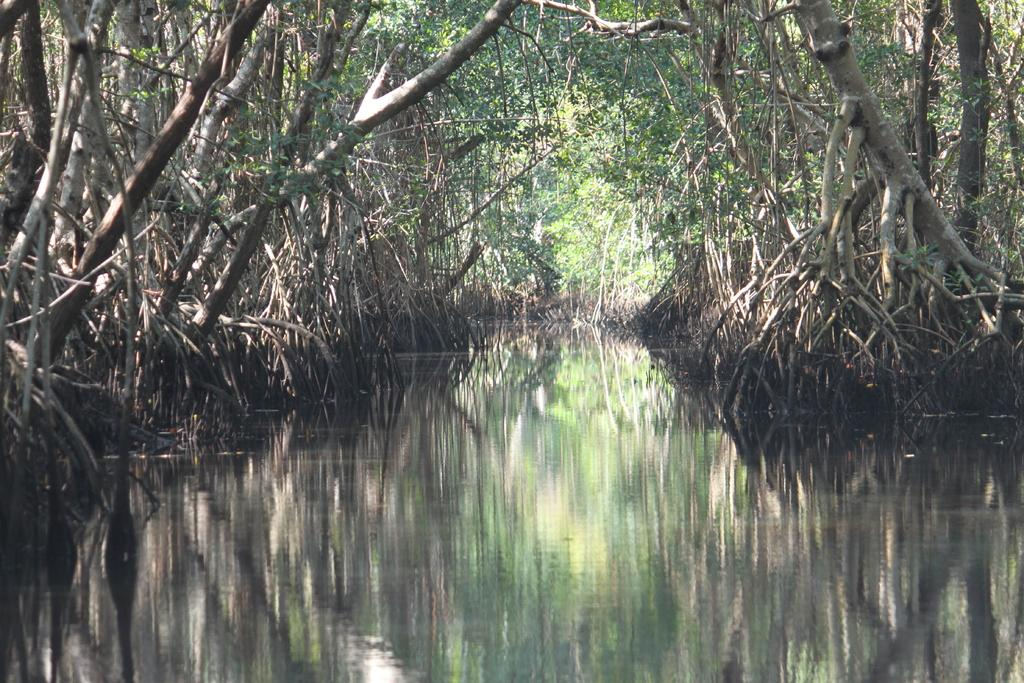What is visible in the image? Water is visible in the image. What is the condition of the trees near the water? The trees near the water are dried. What type of trees can be seen in the background? There are many green trees in the background of the image. What type of mask is the guide wearing while working with the carpenter in the image? There is no guide, carpenter, or mask present in the image. 